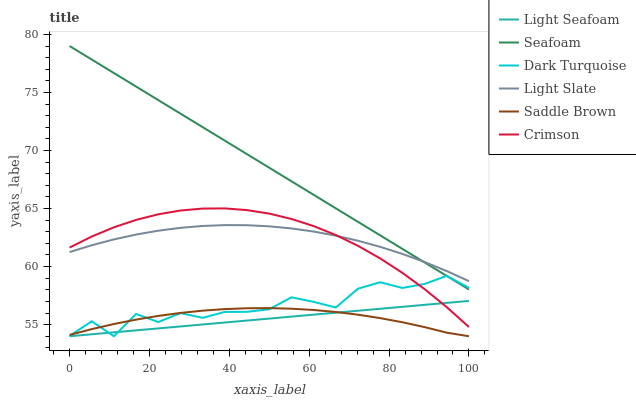Does Dark Turquoise have the minimum area under the curve?
Answer yes or no. No. Does Dark Turquoise have the maximum area under the curve?
Answer yes or no. No. Is Seafoam the smoothest?
Answer yes or no. No. Is Seafoam the roughest?
Answer yes or no. No. Does Seafoam have the lowest value?
Answer yes or no. No. Does Dark Turquoise have the highest value?
Answer yes or no. No. Is Crimson less than Seafoam?
Answer yes or no. Yes. Is Seafoam greater than Crimson?
Answer yes or no. Yes. Does Crimson intersect Seafoam?
Answer yes or no. No. 